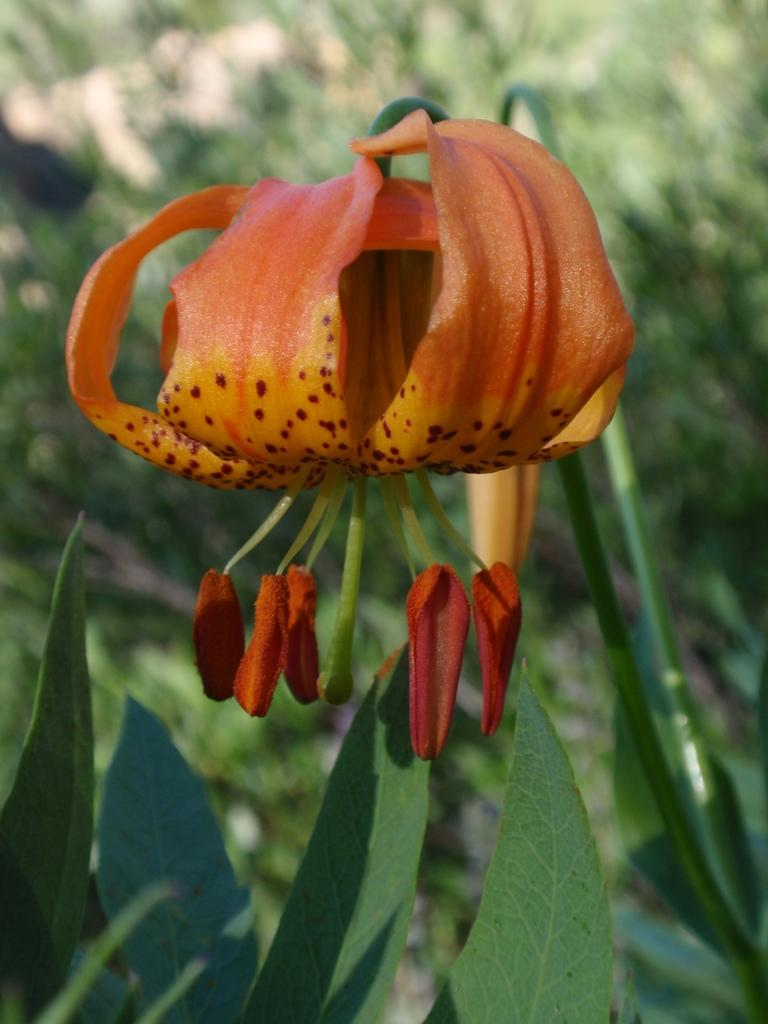What type of plant is visible in the image? There is a flower in the image. What parts of the flower can be seen? The flower has leaves and a stem. What type of vegetation is visible behind the flower? There is grass behind the flower in the image. What type of sound does the squirrel make while running on the sand in the image? There is no squirrel or sand present in the image; it features a flower with leaves and a stem, and grass in the background. 